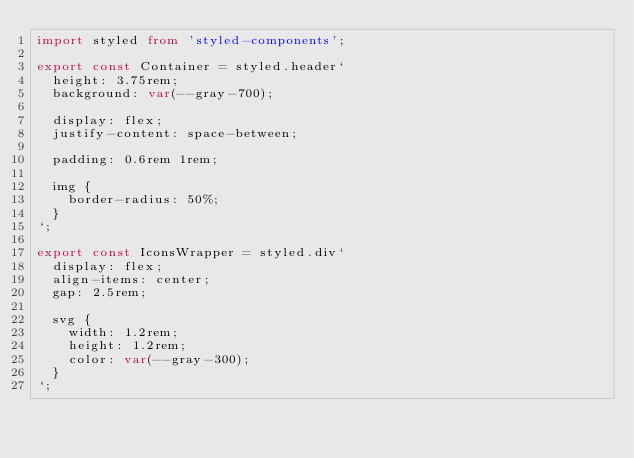<code> <loc_0><loc_0><loc_500><loc_500><_TypeScript_>import styled from 'styled-components';

export const Container = styled.header`
  height: 3.75rem;
  background: var(--gray-700);

  display: flex;
  justify-content: space-between;

  padding: 0.6rem 1rem;

  img {
    border-radius: 50%;
  }
`;

export const IconsWrapper = styled.div`
  display: flex;
  align-items: center;
  gap: 2.5rem;

  svg {
    width: 1.2rem;
    height: 1.2rem;
    color: var(--gray-300);
  }
`;
</code> 